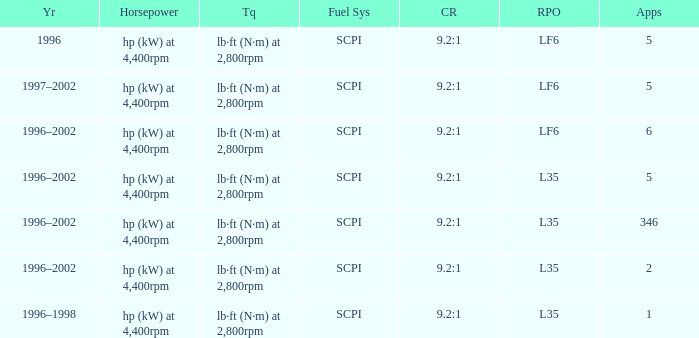What's the compression ratio of the model with L35 RPO and 5 applications? 9.2:1. 